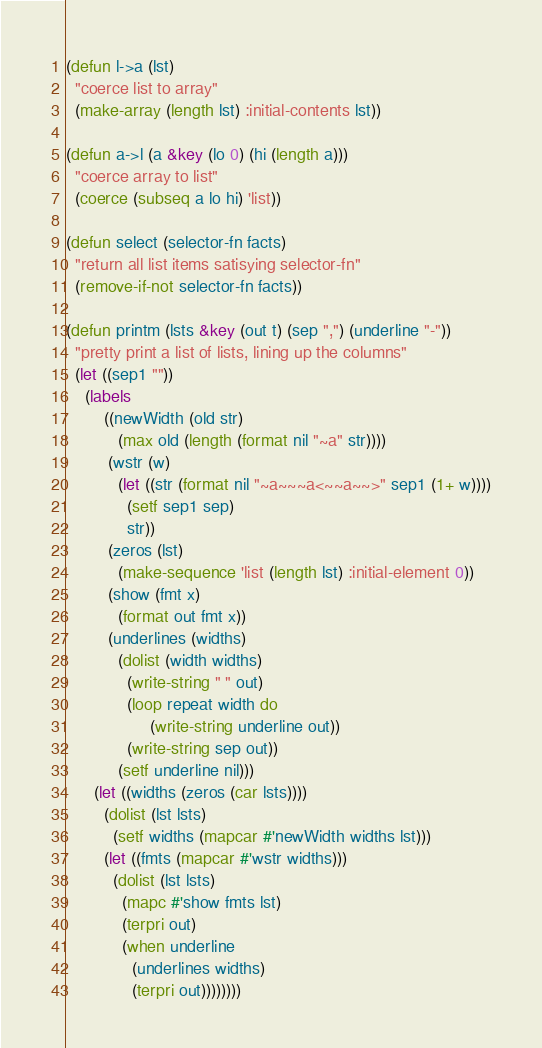Convert code to text. <code><loc_0><loc_0><loc_500><loc_500><_Lisp_>
(defun l->a (lst)
  "coerce list to array"
  (make-array (length lst) :initial-contents lst))

(defun a->l (a &key (lo 0) (hi (length a)))
  "coerce array to list"
  (coerce (subseq a lo hi) 'list))

(defun select (selector-fn facts)
  "return all list items satisying selector-fn"
  (remove-if-not selector-fn facts))

(defun printm (lsts &key (out t) (sep ",") (underline "-"))
  "pretty print a list of lists, lining up the columns"
  (let ((sep1 ""))
    (labels
        ((newWidth (old str)
           (max old (length (format nil "~a" str))))
         (wstr (w)
           (let ((str (format nil "~a~~~a<~~a~~>" sep1 (1+ w))))
             (setf sep1 sep)
             str))
         (zeros (lst)
           (make-sequence 'list (length lst) :initial-element 0))
         (show (fmt x)
           (format out fmt x))
         (underlines (widths)
           (dolist (width widths)
             (write-string " " out)
             (loop repeat width do
                  (write-string underline out))
             (write-string sep out))
           (setf underline nil)))
      (let ((widths (zeros (car lsts))))
        (dolist (lst lsts)
          (setf widths (mapcar #'newWidth widths lst)))
        (let ((fmts (mapcar #'wstr widths)))
          (dolist (lst lsts)
            (mapc #'show fmts lst)
            (terpri out)
            (when underline
              (underlines widths)
              (terpri out))))))))
</code> 